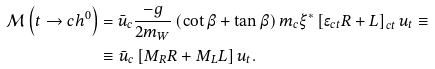<formula> <loc_0><loc_0><loc_500><loc_500>\mathcal { M } \left ( t \rightarrow c h ^ { 0 } \right ) & = \bar { u } _ { c } \frac { - g } { 2 m _ { W } } \left ( \cot \beta + \tan \beta \right ) m _ { c } \xi ^ { * } \left [ \epsilon _ { c t } R + L \right ] _ { c t } u _ { t } \equiv \\ & \equiv \bar { u } _ { c } \left [ M _ { R } R + M _ { L } L \right ] u _ { t } .</formula> 